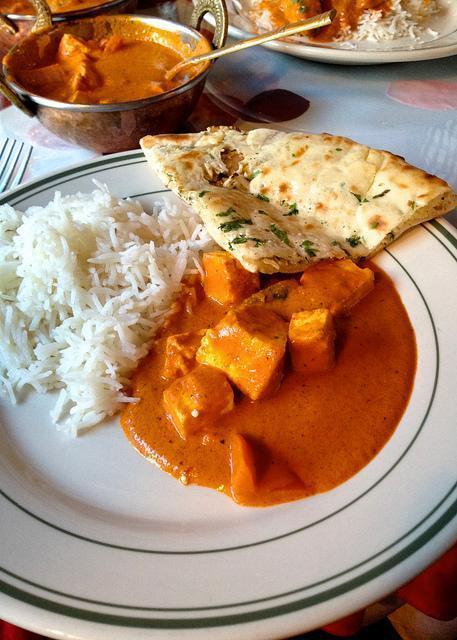How many people are standing up?
Give a very brief answer. 0. 